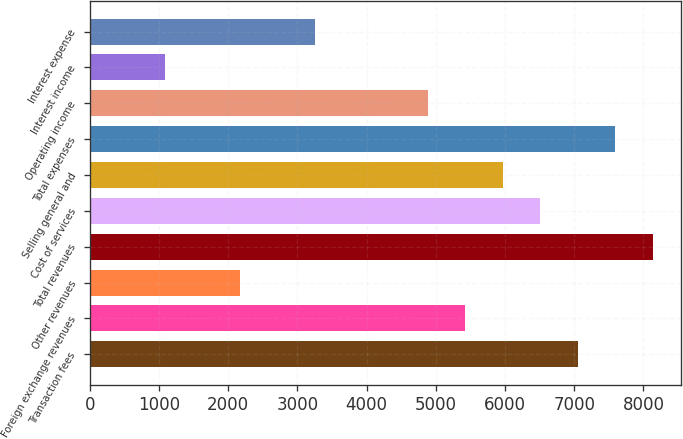<chart> <loc_0><loc_0><loc_500><loc_500><bar_chart><fcel>Transaction fees<fcel>Foreign exchange revenues<fcel>Other revenues<fcel>Total revenues<fcel>Cost of services<fcel>Selling general and<fcel>Total expenses<fcel>Operating income<fcel>Interest income<fcel>Interest expense<nl><fcel>7049.63<fcel>5422.91<fcel>2169.47<fcel>8134.11<fcel>6507.39<fcel>5965.15<fcel>7591.87<fcel>4880.67<fcel>1084.99<fcel>3253.95<nl></chart> 